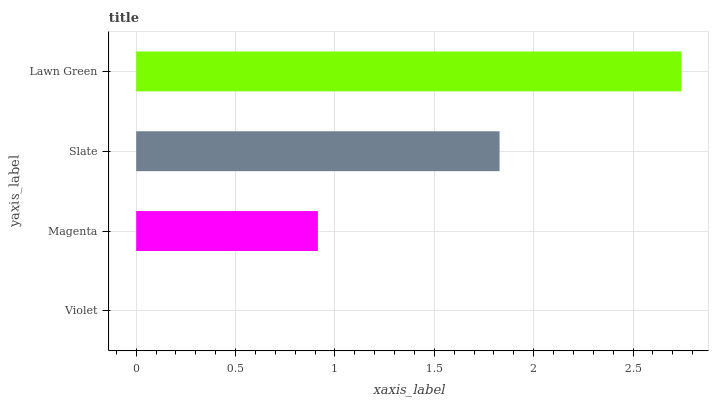Is Violet the minimum?
Answer yes or no. Yes. Is Lawn Green the maximum?
Answer yes or no. Yes. Is Magenta the minimum?
Answer yes or no. No. Is Magenta the maximum?
Answer yes or no. No. Is Magenta greater than Violet?
Answer yes or no. Yes. Is Violet less than Magenta?
Answer yes or no. Yes. Is Violet greater than Magenta?
Answer yes or no. No. Is Magenta less than Violet?
Answer yes or no. No. Is Slate the high median?
Answer yes or no. Yes. Is Magenta the low median?
Answer yes or no. Yes. Is Violet the high median?
Answer yes or no. No. Is Violet the low median?
Answer yes or no. No. 